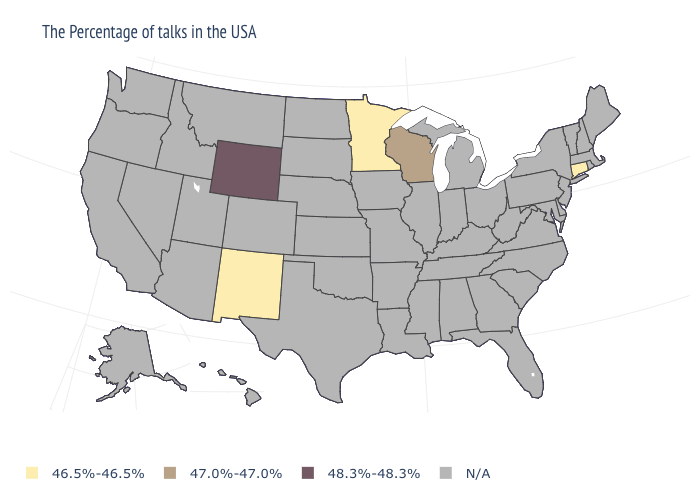Name the states that have a value in the range 47.0%-47.0%?
Be succinct. Wisconsin. What is the value of Colorado?
Short answer required. N/A. Does the map have missing data?
Give a very brief answer. Yes. What is the highest value in the USA?
Write a very short answer. 48.3%-48.3%. How many symbols are there in the legend?
Keep it brief. 4. Name the states that have a value in the range 48.3%-48.3%?
Be succinct. Wyoming. Name the states that have a value in the range 46.5%-46.5%?
Concise answer only. Connecticut, Minnesota, New Mexico. What is the value of Connecticut?
Quick response, please. 46.5%-46.5%. Does Wyoming have the lowest value in the West?
Give a very brief answer. No. Does New Mexico have the highest value in the West?
Short answer required. No. What is the value of New York?
Write a very short answer. N/A. What is the value of South Dakota?
Short answer required. N/A. Name the states that have a value in the range 48.3%-48.3%?
Write a very short answer. Wyoming. 